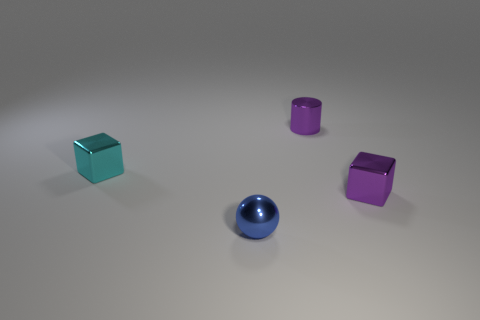Do these objects serve a specific purpose? The image alone does not provide enough context to determine a specific purpose. They could be used in various ways, such as game pieces, educational tools for teaching geometry or color theory, or simply as decorative elements. Are there any reflective surfaces on the objects? Yes, each object in the image has a reflective surface. Their glossy finish catches the light, creating subtle reflections and highlights that add to their visual appeal. 